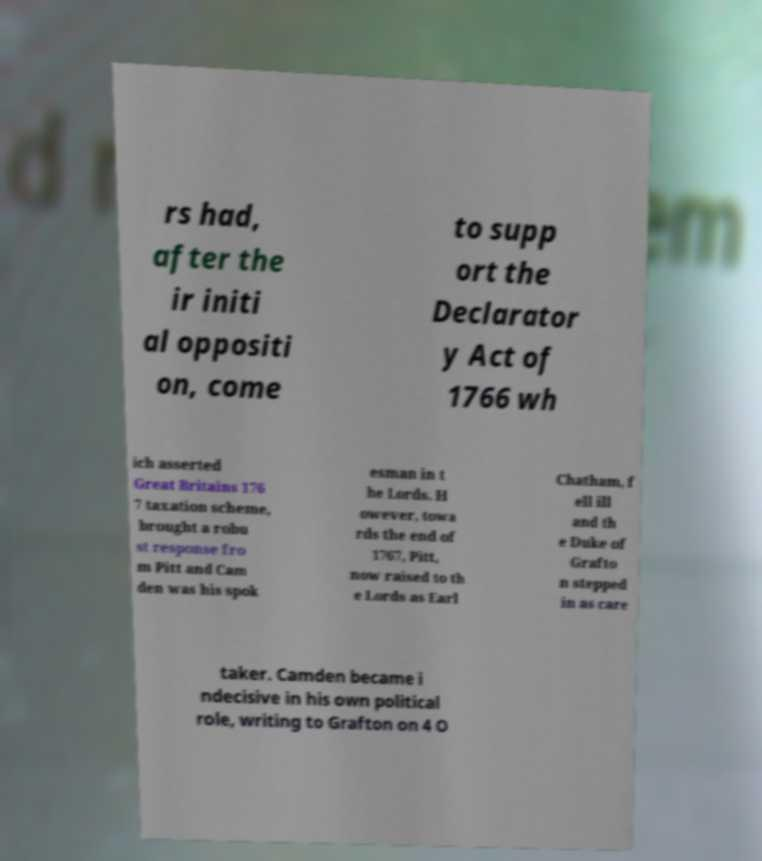What messages or text are displayed in this image? I need them in a readable, typed format. rs had, after the ir initi al oppositi on, come to supp ort the Declarator y Act of 1766 wh ich asserted Great Britains 176 7 taxation scheme, brought a robu st response fro m Pitt and Cam den was his spok esman in t he Lords. H owever, towa rds the end of 1767, Pitt, now raised to th e Lords as Earl Chatham, f ell ill and th e Duke of Grafto n stepped in as care taker. Camden became i ndecisive in his own political role, writing to Grafton on 4 O 